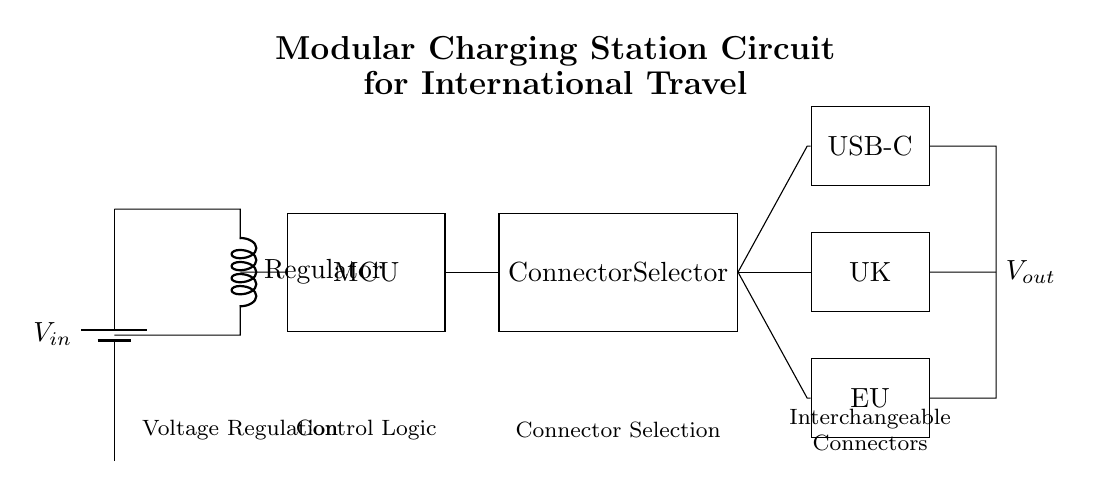What type of circuit is represented? The circuit is a modular charging station designed for international travel, indicated by its interchangeable connectors and voltage regulation components.
Answer: Modular charging station What components are involved in the voltage regulation? The voltage regulation section consists of a voltage regulator shown as a cute inductor, handling the regulation of input voltage to a usable output level.
Answer: Voltage regulator How many types of connectors are present in the circuit? There are three types of connectors available in the circuit: USB-C, UK, and EU, as labeled on the diagram.
Answer: Three What does the MCU stand for in this circuit? MCU stands for Microcontroller Unit, which is indicated in the diagram as the control logic component that manages the charging functionality based on input from the connector selector.
Answer: Microcontroller Unit How is the connection between the microcontroller and the connector selector made? The connection is made through a direct short path from the microcontroller to the connector selector, allowing for signal transfer for functionality selection.
Answer: Direct connection What is the purpose of the connector selector in the circuit? The connector selector determines which output connector is activated for charging, allowing the user to choose the appropriate plug based on the region they are in.
Answer: Selecting output connector What happens to the voltage at the output? The output voltage remains regulated and consistent, as indicated by the inclusion of the voltage regulator that ensures a steady output suitable for devices.
Answer: Regulated output voltage 